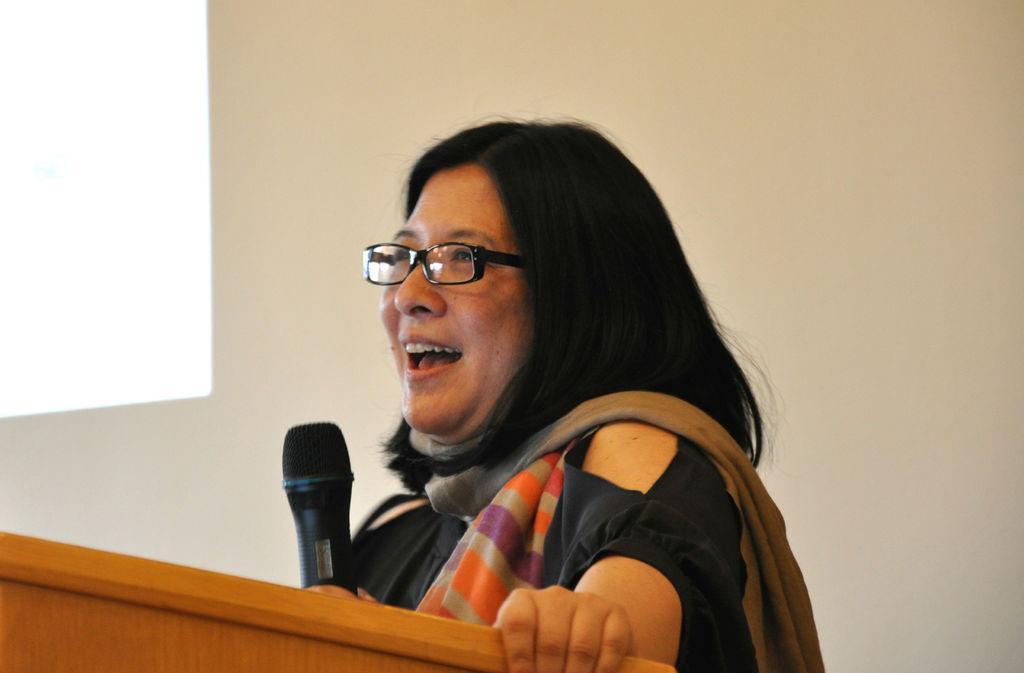How would you summarize this image in a sentence or two? In this image there is a woman standing in the center and speaking and smiling holding a mic in her hand. In the front there is a wooden stand. 